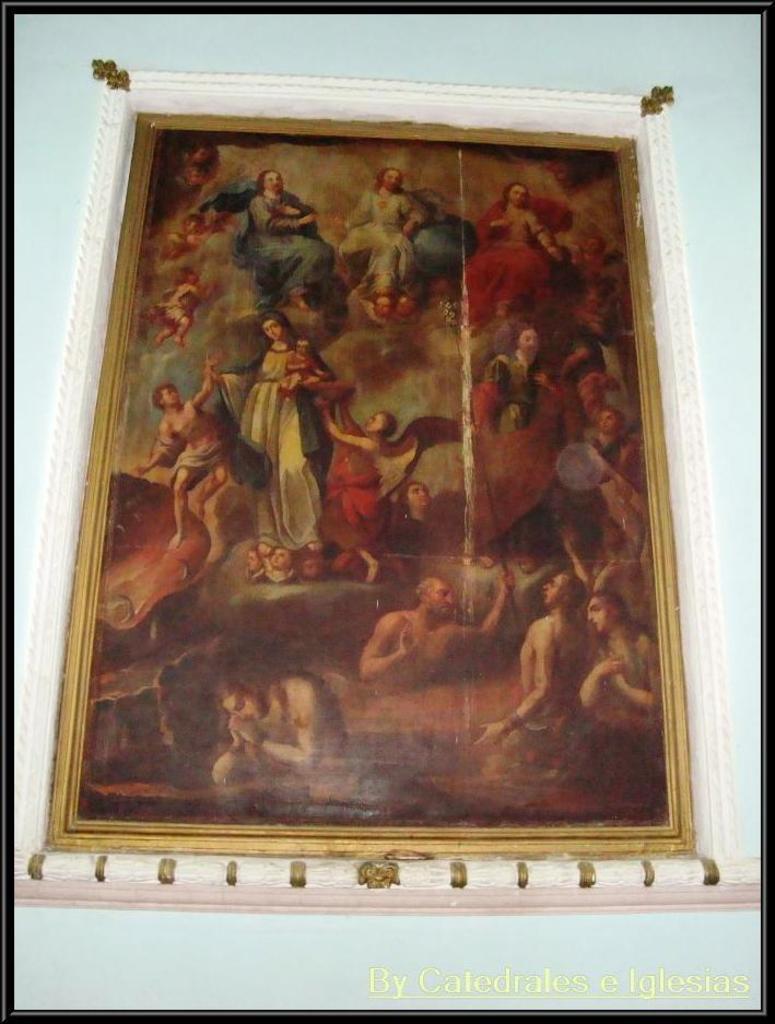Could you give a brief overview of what you see in this image? In the center of the image there is a wall. On the wall, we can see one photo frame. On the photo frame, we can see a few people. In the bottom of the image, we can see some text. And we can see the black color border around the image. 